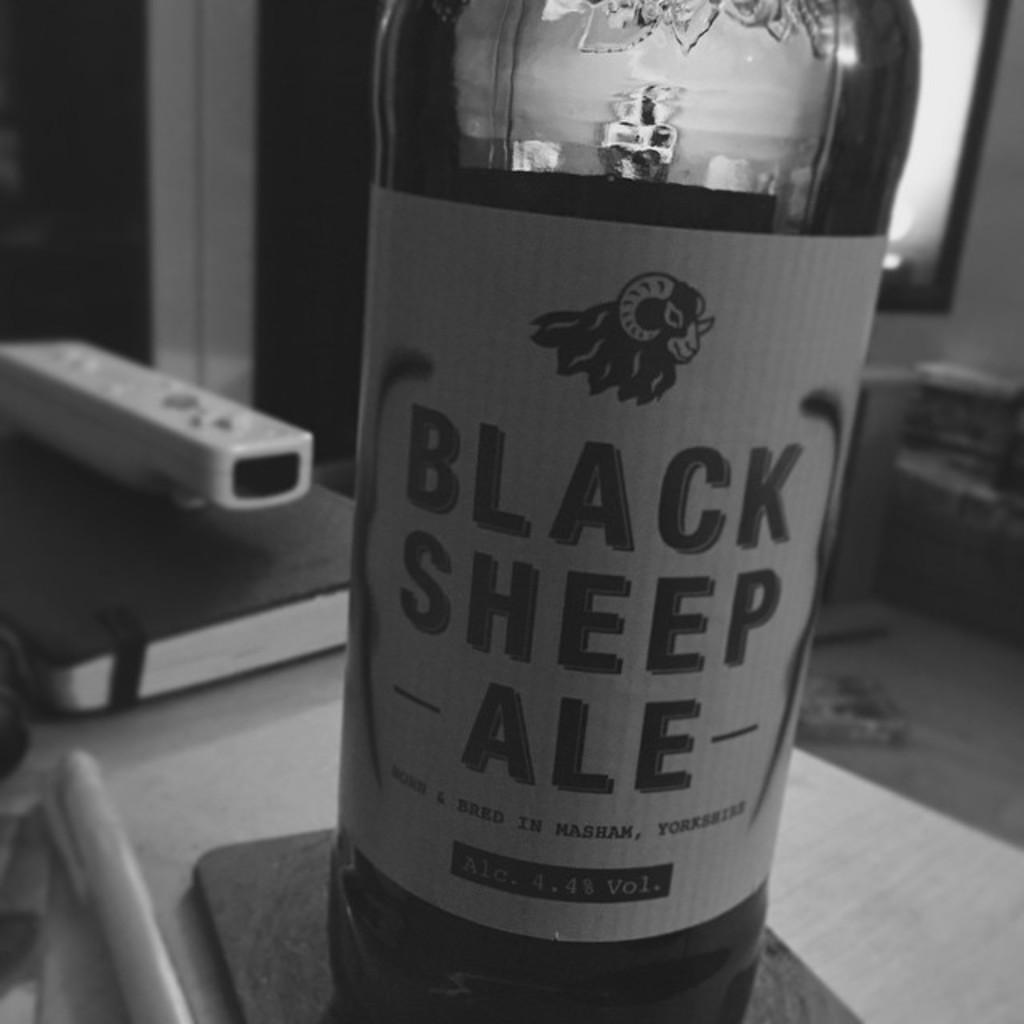<image>
Write a terse but informative summary of the picture. A bottle of Black sheep ale on a white label. 